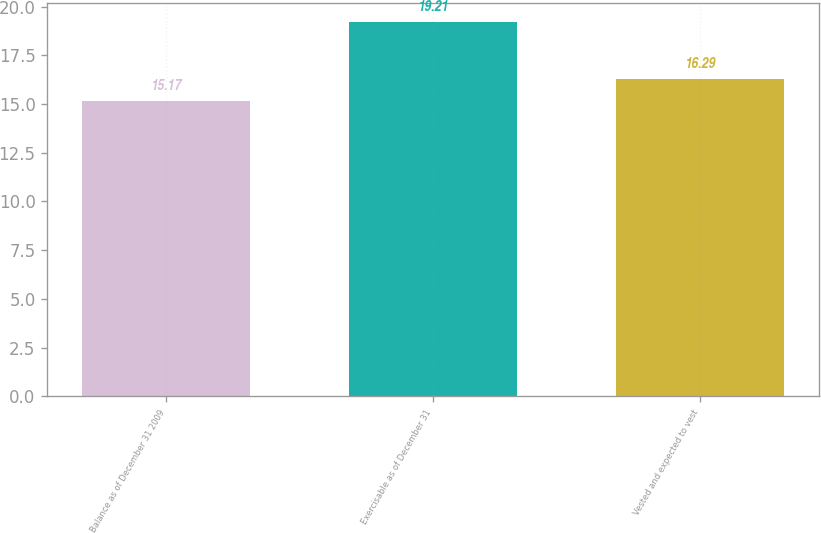Convert chart. <chart><loc_0><loc_0><loc_500><loc_500><bar_chart><fcel>Balance as of December 31 2009<fcel>Exercisable as of December 31<fcel>Vested and expected to vest<nl><fcel>15.17<fcel>19.21<fcel>16.29<nl></chart> 